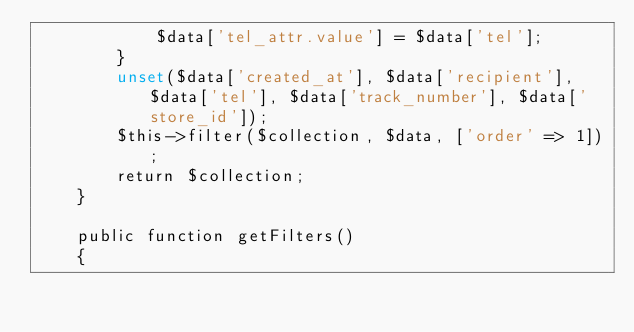<code> <loc_0><loc_0><loc_500><loc_500><_PHP_>            $data['tel_attr.value'] = $data['tel'];
        }
        unset($data['created_at'], $data['recipient'], $data['tel'], $data['track_number'], $data['store_id']);
        $this->filter($collection, $data, ['order' => 1]);
        return $collection;
    }

    public function getFilters()
    {</code> 